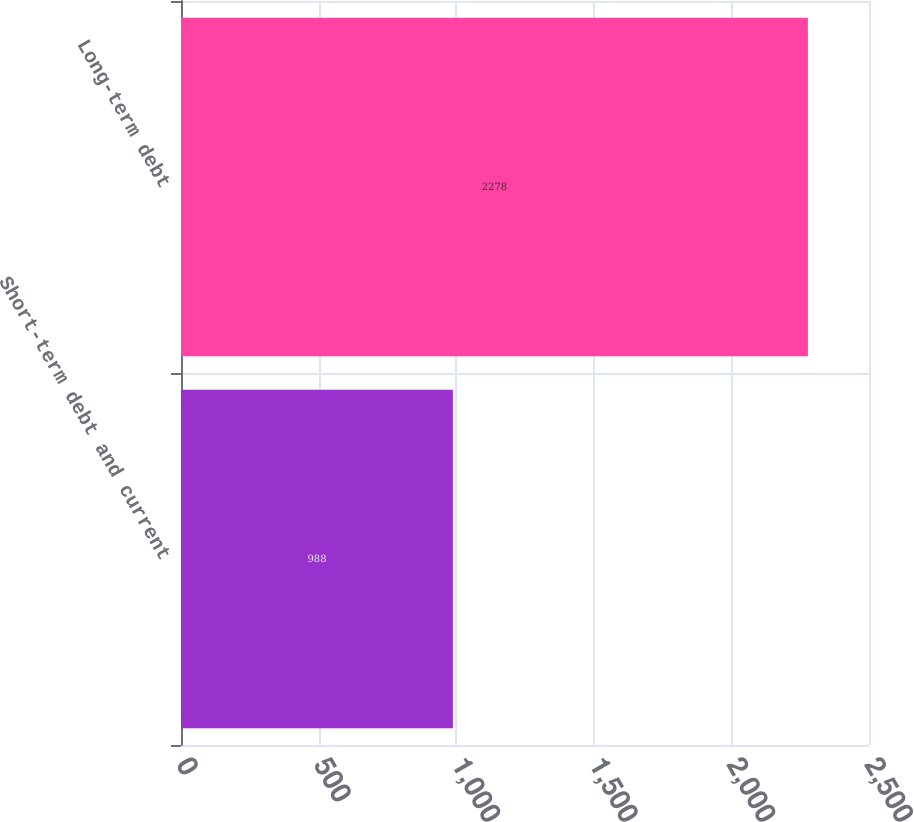<chart> <loc_0><loc_0><loc_500><loc_500><bar_chart><fcel>Short-term debt and current<fcel>Long-term debt<nl><fcel>988<fcel>2278<nl></chart> 